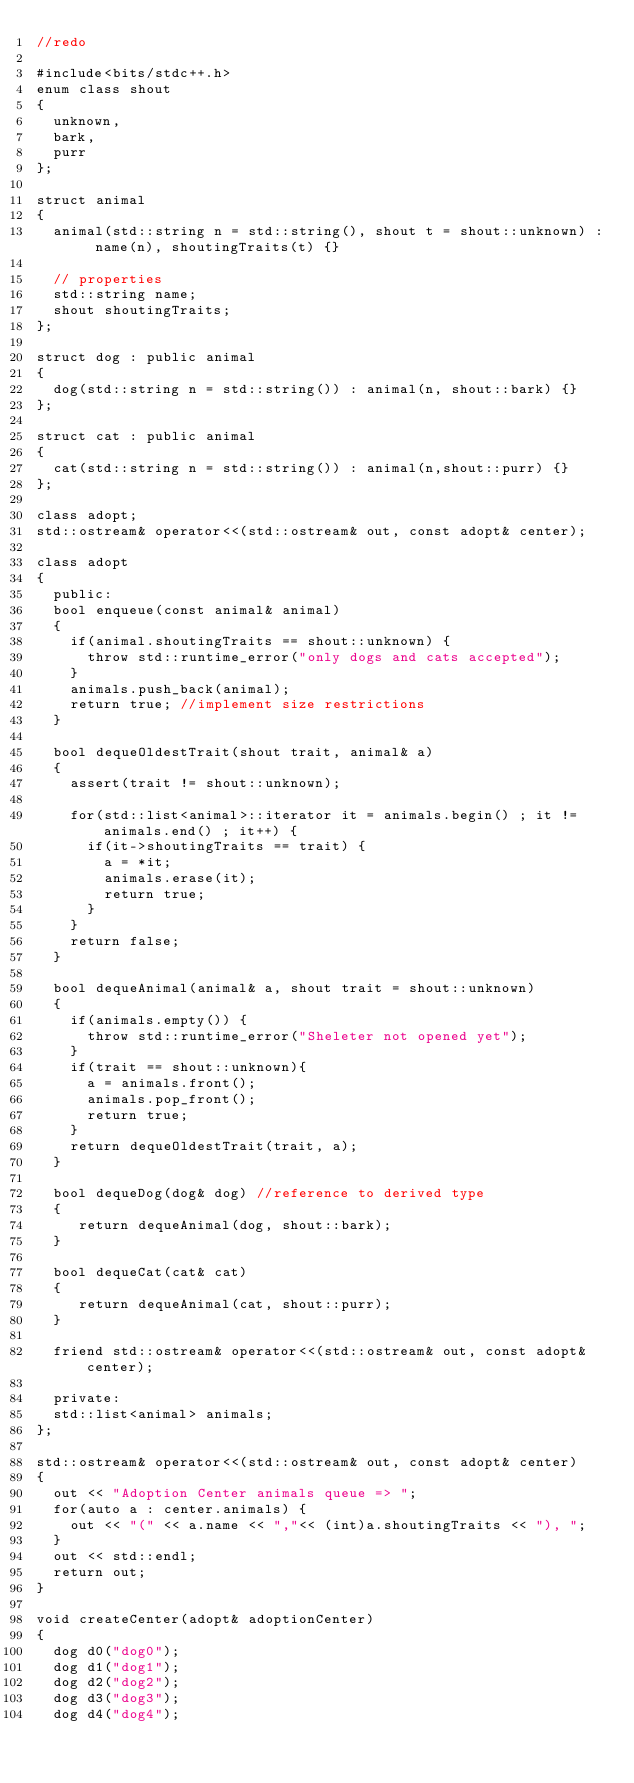<code> <loc_0><loc_0><loc_500><loc_500><_C++_>//redo

#include<bits/stdc++.h>
enum class shout
{
  unknown,
  bark,
  purr
};

struct animal
{
  animal(std::string n = std::string(), shout t = shout::unknown) : name(n), shoutingTraits(t) {}

  // properties
  std::string name;
  shout shoutingTraits;
};

struct dog : public animal
{
  dog(std::string n = std::string()) : animal(n, shout::bark) {}
};

struct cat : public animal
{
  cat(std::string n = std::string()) : animal(n,shout::purr) {}
};

class adopt;
std::ostream& operator<<(std::ostream& out, const adopt& center);

class adopt
{
  public:
  bool enqueue(const animal& animal)
  {
    if(animal.shoutingTraits == shout::unknown) {
      throw std::runtime_error("only dogs and cats accepted");
    }
    animals.push_back(animal);
    return true; //implement size restrictions
  }

  bool dequeOldestTrait(shout trait, animal& a)
  {
    assert(trait != shout::unknown);

    for(std::list<animal>::iterator it = animals.begin() ; it != animals.end() ; it++) {
      if(it->shoutingTraits == trait) {
        a = *it;
        animals.erase(it);
        return true;
      }
    }
    return false;
  }

  bool dequeAnimal(animal& a, shout trait = shout::unknown)
  {
    if(animals.empty()) {
      throw std::runtime_error("Sheleter not opened yet");
    }
    if(trait == shout::unknown){
      a = animals.front();
      animals.pop_front();
      return true;
    }
    return dequeOldestTrait(trait, a);
  }

  bool dequeDog(dog& dog) //reference to derived type
  {
     return dequeAnimal(dog, shout::bark);
  }

  bool dequeCat(cat& cat)
  {
     return dequeAnimal(cat, shout::purr);
  }

  friend std::ostream& operator<<(std::ostream& out, const adopt& center);

  private:
  std::list<animal> animals;
};

std::ostream& operator<<(std::ostream& out, const adopt& center)
{
  out << "Adoption Center animals queue => ";
  for(auto a : center.animals) {
    out << "(" << a.name << ","<< (int)a.shoutingTraits << "), ";
  }
  out << std::endl;
  return out;
}

void createCenter(adopt& adoptionCenter)
{
  dog d0("dog0");
  dog d1("dog1");
  dog d2("dog2");
  dog d3("dog3");
  dog d4("dog4");</code> 